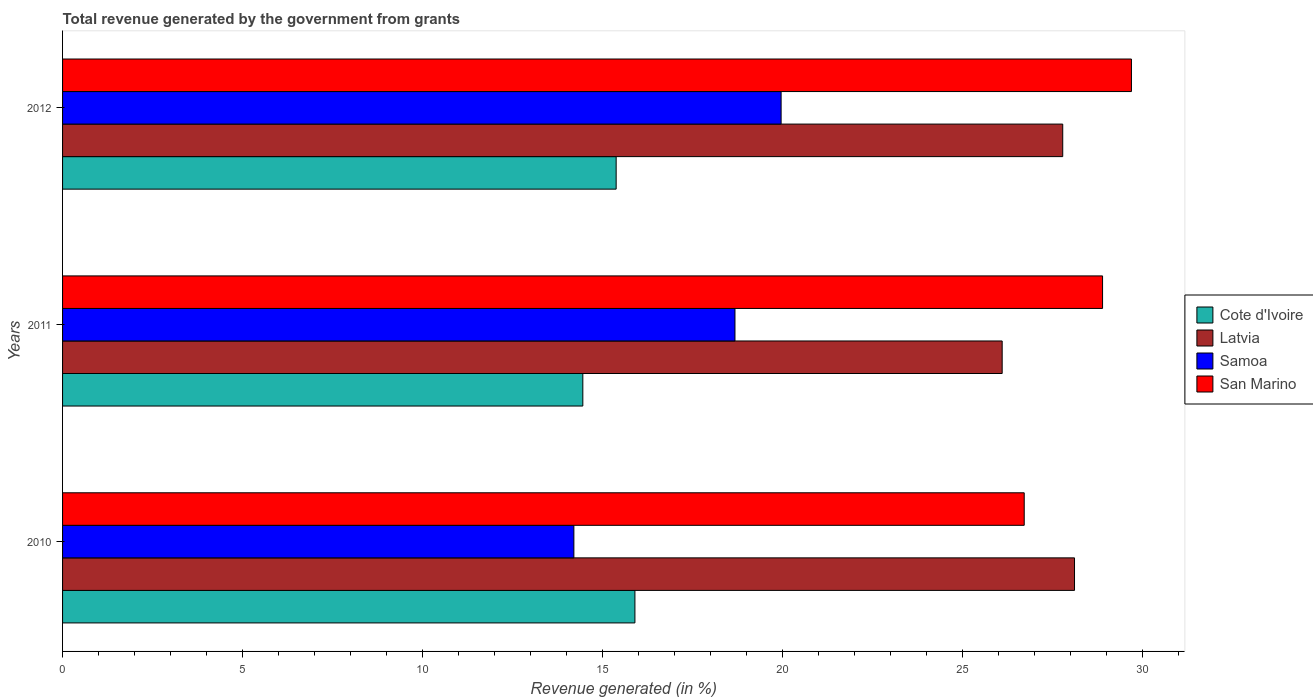How many groups of bars are there?
Provide a succinct answer. 3. Are the number of bars on each tick of the Y-axis equal?
Provide a short and direct response. Yes. What is the label of the 3rd group of bars from the top?
Offer a terse response. 2010. What is the total revenue generated in Samoa in 2011?
Ensure brevity in your answer.  18.68. Across all years, what is the maximum total revenue generated in Cote d'Ivoire?
Offer a terse response. 15.9. Across all years, what is the minimum total revenue generated in Samoa?
Provide a succinct answer. 14.2. In which year was the total revenue generated in Latvia minimum?
Offer a terse response. 2011. What is the total total revenue generated in Latvia in the graph?
Offer a terse response. 81.99. What is the difference between the total revenue generated in Samoa in 2010 and that in 2012?
Ensure brevity in your answer.  -5.76. What is the difference between the total revenue generated in Latvia in 2010 and the total revenue generated in Samoa in 2012?
Keep it short and to the point. 8.15. What is the average total revenue generated in San Marino per year?
Provide a short and direct response. 28.43. In the year 2012, what is the difference between the total revenue generated in San Marino and total revenue generated in Samoa?
Ensure brevity in your answer.  9.73. In how many years, is the total revenue generated in Cote d'Ivoire greater than 14 %?
Provide a succinct answer. 3. What is the ratio of the total revenue generated in Cote d'Ivoire in 2010 to that in 2011?
Give a very brief answer. 1.1. Is the total revenue generated in San Marino in 2010 less than that in 2012?
Offer a terse response. Yes. Is the difference between the total revenue generated in San Marino in 2011 and 2012 greater than the difference between the total revenue generated in Samoa in 2011 and 2012?
Give a very brief answer. Yes. What is the difference between the highest and the second highest total revenue generated in Samoa?
Offer a very short reply. 1.28. What is the difference between the highest and the lowest total revenue generated in Latvia?
Offer a terse response. 2.01. In how many years, is the total revenue generated in San Marino greater than the average total revenue generated in San Marino taken over all years?
Give a very brief answer. 2. Is it the case that in every year, the sum of the total revenue generated in Samoa and total revenue generated in Cote d'Ivoire is greater than the sum of total revenue generated in Latvia and total revenue generated in San Marino?
Keep it short and to the point. No. What does the 2nd bar from the top in 2010 represents?
Provide a succinct answer. Samoa. What does the 4th bar from the bottom in 2011 represents?
Ensure brevity in your answer.  San Marino. How many years are there in the graph?
Provide a succinct answer. 3. Are the values on the major ticks of X-axis written in scientific E-notation?
Offer a terse response. No. Does the graph contain any zero values?
Make the answer very short. No. Does the graph contain grids?
Give a very brief answer. No. Where does the legend appear in the graph?
Offer a very short reply. Center right. How are the legend labels stacked?
Provide a short and direct response. Vertical. What is the title of the graph?
Your response must be concise. Total revenue generated by the government from grants. What is the label or title of the X-axis?
Keep it short and to the point. Revenue generated (in %). What is the Revenue generated (in %) in Cote d'Ivoire in 2010?
Offer a very short reply. 15.9. What is the Revenue generated (in %) of Latvia in 2010?
Your answer should be compact. 28.11. What is the Revenue generated (in %) of Samoa in 2010?
Offer a very short reply. 14.2. What is the Revenue generated (in %) in San Marino in 2010?
Provide a short and direct response. 26.71. What is the Revenue generated (in %) in Cote d'Ivoire in 2011?
Your answer should be compact. 14.45. What is the Revenue generated (in %) of Latvia in 2011?
Keep it short and to the point. 26.1. What is the Revenue generated (in %) of Samoa in 2011?
Your answer should be compact. 18.68. What is the Revenue generated (in %) in San Marino in 2011?
Ensure brevity in your answer.  28.89. What is the Revenue generated (in %) in Cote d'Ivoire in 2012?
Your answer should be compact. 15.38. What is the Revenue generated (in %) of Latvia in 2012?
Keep it short and to the point. 27.78. What is the Revenue generated (in %) in Samoa in 2012?
Give a very brief answer. 19.96. What is the Revenue generated (in %) in San Marino in 2012?
Your answer should be very brief. 29.69. Across all years, what is the maximum Revenue generated (in %) in Cote d'Ivoire?
Ensure brevity in your answer.  15.9. Across all years, what is the maximum Revenue generated (in %) of Latvia?
Offer a terse response. 28.11. Across all years, what is the maximum Revenue generated (in %) in Samoa?
Provide a succinct answer. 19.96. Across all years, what is the maximum Revenue generated (in %) of San Marino?
Provide a succinct answer. 29.69. Across all years, what is the minimum Revenue generated (in %) of Cote d'Ivoire?
Provide a succinct answer. 14.45. Across all years, what is the minimum Revenue generated (in %) of Latvia?
Give a very brief answer. 26.1. Across all years, what is the minimum Revenue generated (in %) in Samoa?
Give a very brief answer. 14.2. Across all years, what is the minimum Revenue generated (in %) of San Marino?
Provide a succinct answer. 26.71. What is the total Revenue generated (in %) of Cote d'Ivoire in the graph?
Provide a short and direct response. 45.73. What is the total Revenue generated (in %) of Latvia in the graph?
Your answer should be compact. 81.99. What is the total Revenue generated (in %) in Samoa in the graph?
Offer a very short reply. 52.84. What is the total Revenue generated (in %) in San Marino in the graph?
Your answer should be very brief. 85.29. What is the difference between the Revenue generated (in %) of Cote d'Ivoire in 2010 and that in 2011?
Your answer should be very brief. 1.45. What is the difference between the Revenue generated (in %) in Latvia in 2010 and that in 2011?
Your response must be concise. 2.01. What is the difference between the Revenue generated (in %) in Samoa in 2010 and that in 2011?
Ensure brevity in your answer.  -4.47. What is the difference between the Revenue generated (in %) of San Marino in 2010 and that in 2011?
Offer a terse response. -2.18. What is the difference between the Revenue generated (in %) in Cote d'Ivoire in 2010 and that in 2012?
Offer a very short reply. 0.52. What is the difference between the Revenue generated (in %) in Latvia in 2010 and that in 2012?
Offer a very short reply. 0.33. What is the difference between the Revenue generated (in %) of Samoa in 2010 and that in 2012?
Your response must be concise. -5.76. What is the difference between the Revenue generated (in %) in San Marino in 2010 and that in 2012?
Give a very brief answer. -2.98. What is the difference between the Revenue generated (in %) of Cote d'Ivoire in 2011 and that in 2012?
Provide a succinct answer. -0.93. What is the difference between the Revenue generated (in %) of Latvia in 2011 and that in 2012?
Offer a very short reply. -1.68. What is the difference between the Revenue generated (in %) of Samoa in 2011 and that in 2012?
Your answer should be compact. -1.28. What is the difference between the Revenue generated (in %) in San Marino in 2011 and that in 2012?
Offer a terse response. -0.8. What is the difference between the Revenue generated (in %) in Cote d'Ivoire in 2010 and the Revenue generated (in %) in Latvia in 2011?
Ensure brevity in your answer.  -10.2. What is the difference between the Revenue generated (in %) of Cote d'Ivoire in 2010 and the Revenue generated (in %) of Samoa in 2011?
Give a very brief answer. -2.78. What is the difference between the Revenue generated (in %) in Cote d'Ivoire in 2010 and the Revenue generated (in %) in San Marino in 2011?
Provide a succinct answer. -12.99. What is the difference between the Revenue generated (in %) in Latvia in 2010 and the Revenue generated (in %) in Samoa in 2011?
Your answer should be compact. 9.43. What is the difference between the Revenue generated (in %) of Latvia in 2010 and the Revenue generated (in %) of San Marino in 2011?
Keep it short and to the point. -0.78. What is the difference between the Revenue generated (in %) in Samoa in 2010 and the Revenue generated (in %) in San Marino in 2011?
Offer a very short reply. -14.69. What is the difference between the Revenue generated (in %) in Cote d'Ivoire in 2010 and the Revenue generated (in %) in Latvia in 2012?
Your answer should be very brief. -11.88. What is the difference between the Revenue generated (in %) in Cote d'Ivoire in 2010 and the Revenue generated (in %) in Samoa in 2012?
Offer a very short reply. -4.06. What is the difference between the Revenue generated (in %) in Cote d'Ivoire in 2010 and the Revenue generated (in %) in San Marino in 2012?
Your answer should be compact. -13.79. What is the difference between the Revenue generated (in %) in Latvia in 2010 and the Revenue generated (in %) in Samoa in 2012?
Ensure brevity in your answer.  8.15. What is the difference between the Revenue generated (in %) in Latvia in 2010 and the Revenue generated (in %) in San Marino in 2012?
Your answer should be compact. -1.58. What is the difference between the Revenue generated (in %) in Samoa in 2010 and the Revenue generated (in %) in San Marino in 2012?
Offer a very short reply. -15.49. What is the difference between the Revenue generated (in %) in Cote d'Ivoire in 2011 and the Revenue generated (in %) in Latvia in 2012?
Your answer should be very brief. -13.33. What is the difference between the Revenue generated (in %) in Cote d'Ivoire in 2011 and the Revenue generated (in %) in Samoa in 2012?
Ensure brevity in your answer.  -5.51. What is the difference between the Revenue generated (in %) in Cote d'Ivoire in 2011 and the Revenue generated (in %) in San Marino in 2012?
Provide a succinct answer. -15.24. What is the difference between the Revenue generated (in %) of Latvia in 2011 and the Revenue generated (in %) of Samoa in 2012?
Provide a succinct answer. 6.14. What is the difference between the Revenue generated (in %) in Latvia in 2011 and the Revenue generated (in %) in San Marino in 2012?
Your answer should be very brief. -3.59. What is the difference between the Revenue generated (in %) in Samoa in 2011 and the Revenue generated (in %) in San Marino in 2012?
Make the answer very short. -11.01. What is the average Revenue generated (in %) of Cote d'Ivoire per year?
Your answer should be compact. 15.24. What is the average Revenue generated (in %) of Latvia per year?
Provide a succinct answer. 27.33. What is the average Revenue generated (in %) of Samoa per year?
Your answer should be compact. 17.61. What is the average Revenue generated (in %) in San Marino per year?
Your answer should be very brief. 28.43. In the year 2010, what is the difference between the Revenue generated (in %) in Cote d'Ivoire and Revenue generated (in %) in Latvia?
Give a very brief answer. -12.21. In the year 2010, what is the difference between the Revenue generated (in %) in Cote d'Ivoire and Revenue generated (in %) in Samoa?
Provide a succinct answer. 1.7. In the year 2010, what is the difference between the Revenue generated (in %) of Cote d'Ivoire and Revenue generated (in %) of San Marino?
Your answer should be compact. -10.81. In the year 2010, what is the difference between the Revenue generated (in %) in Latvia and Revenue generated (in %) in Samoa?
Offer a terse response. 13.91. In the year 2010, what is the difference between the Revenue generated (in %) of Latvia and Revenue generated (in %) of San Marino?
Your answer should be compact. 1.4. In the year 2010, what is the difference between the Revenue generated (in %) of Samoa and Revenue generated (in %) of San Marino?
Ensure brevity in your answer.  -12.51. In the year 2011, what is the difference between the Revenue generated (in %) of Cote d'Ivoire and Revenue generated (in %) of Latvia?
Keep it short and to the point. -11.65. In the year 2011, what is the difference between the Revenue generated (in %) of Cote d'Ivoire and Revenue generated (in %) of Samoa?
Your answer should be compact. -4.23. In the year 2011, what is the difference between the Revenue generated (in %) of Cote d'Ivoire and Revenue generated (in %) of San Marino?
Give a very brief answer. -14.44. In the year 2011, what is the difference between the Revenue generated (in %) of Latvia and Revenue generated (in %) of Samoa?
Your response must be concise. 7.42. In the year 2011, what is the difference between the Revenue generated (in %) of Latvia and Revenue generated (in %) of San Marino?
Provide a succinct answer. -2.79. In the year 2011, what is the difference between the Revenue generated (in %) in Samoa and Revenue generated (in %) in San Marino?
Offer a very short reply. -10.21. In the year 2012, what is the difference between the Revenue generated (in %) of Cote d'Ivoire and Revenue generated (in %) of Latvia?
Keep it short and to the point. -12.4. In the year 2012, what is the difference between the Revenue generated (in %) of Cote d'Ivoire and Revenue generated (in %) of Samoa?
Provide a succinct answer. -4.58. In the year 2012, what is the difference between the Revenue generated (in %) in Cote d'Ivoire and Revenue generated (in %) in San Marino?
Keep it short and to the point. -14.31. In the year 2012, what is the difference between the Revenue generated (in %) of Latvia and Revenue generated (in %) of Samoa?
Give a very brief answer. 7.82. In the year 2012, what is the difference between the Revenue generated (in %) of Latvia and Revenue generated (in %) of San Marino?
Your answer should be compact. -1.91. In the year 2012, what is the difference between the Revenue generated (in %) in Samoa and Revenue generated (in %) in San Marino?
Make the answer very short. -9.73. What is the ratio of the Revenue generated (in %) in Cote d'Ivoire in 2010 to that in 2011?
Offer a very short reply. 1.1. What is the ratio of the Revenue generated (in %) in Latvia in 2010 to that in 2011?
Offer a terse response. 1.08. What is the ratio of the Revenue generated (in %) in Samoa in 2010 to that in 2011?
Your answer should be very brief. 0.76. What is the ratio of the Revenue generated (in %) in San Marino in 2010 to that in 2011?
Make the answer very short. 0.92. What is the ratio of the Revenue generated (in %) in Cote d'Ivoire in 2010 to that in 2012?
Your answer should be very brief. 1.03. What is the ratio of the Revenue generated (in %) of Latvia in 2010 to that in 2012?
Your response must be concise. 1.01. What is the ratio of the Revenue generated (in %) in Samoa in 2010 to that in 2012?
Provide a succinct answer. 0.71. What is the ratio of the Revenue generated (in %) of San Marino in 2010 to that in 2012?
Offer a terse response. 0.9. What is the ratio of the Revenue generated (in %) in Cote d'Ivoire in 2011 to that in 2012?
Offer a terse response. 0.94. What is the ratio of the Revenue generated (in %) in Latvia in 2011 to that in 2012?
Ensure brevity in your answer.  0.94. What is the ratio of the Revenue generated (in %) in Samoa in 2011 to that in 2012?
Provide a short and direct response. 0.94. What is the difference between the highest and the second highest Revenue generated (in %) in Cote d'Ivoire?
Keep it short and to the point. 0.52. What is the difference between the highest and the second highest Revenue generated (in %) in Latvia?
Offer a terse response. 0.33. What is the difference between the highest and the second highest Revenue generated (in %) of Samoa?
Ensure brevity in your answer.  1.28. What is the difference between the highest and the second highest Revenue generated (in %) in San Marino?
Offer a very short reply. 0.8. What is the difference between the highest and the lowest Revenue generated (in %) in Cote d'Ivoire?
Give a very brief answer. 1.45. What is the difference between the highest and the lowest Revenue generated (in %) of Latvia?
Your answer should be compact. 2.01. What is the difference between the highest and the lowest Revenue generated (in %) of Samoa?
Give a very brief answer. 5.76. What is the difference between the highest and the lowest Revenue generated (in %) of San Marino?
Ensure brevity in your answer.  2.98. 